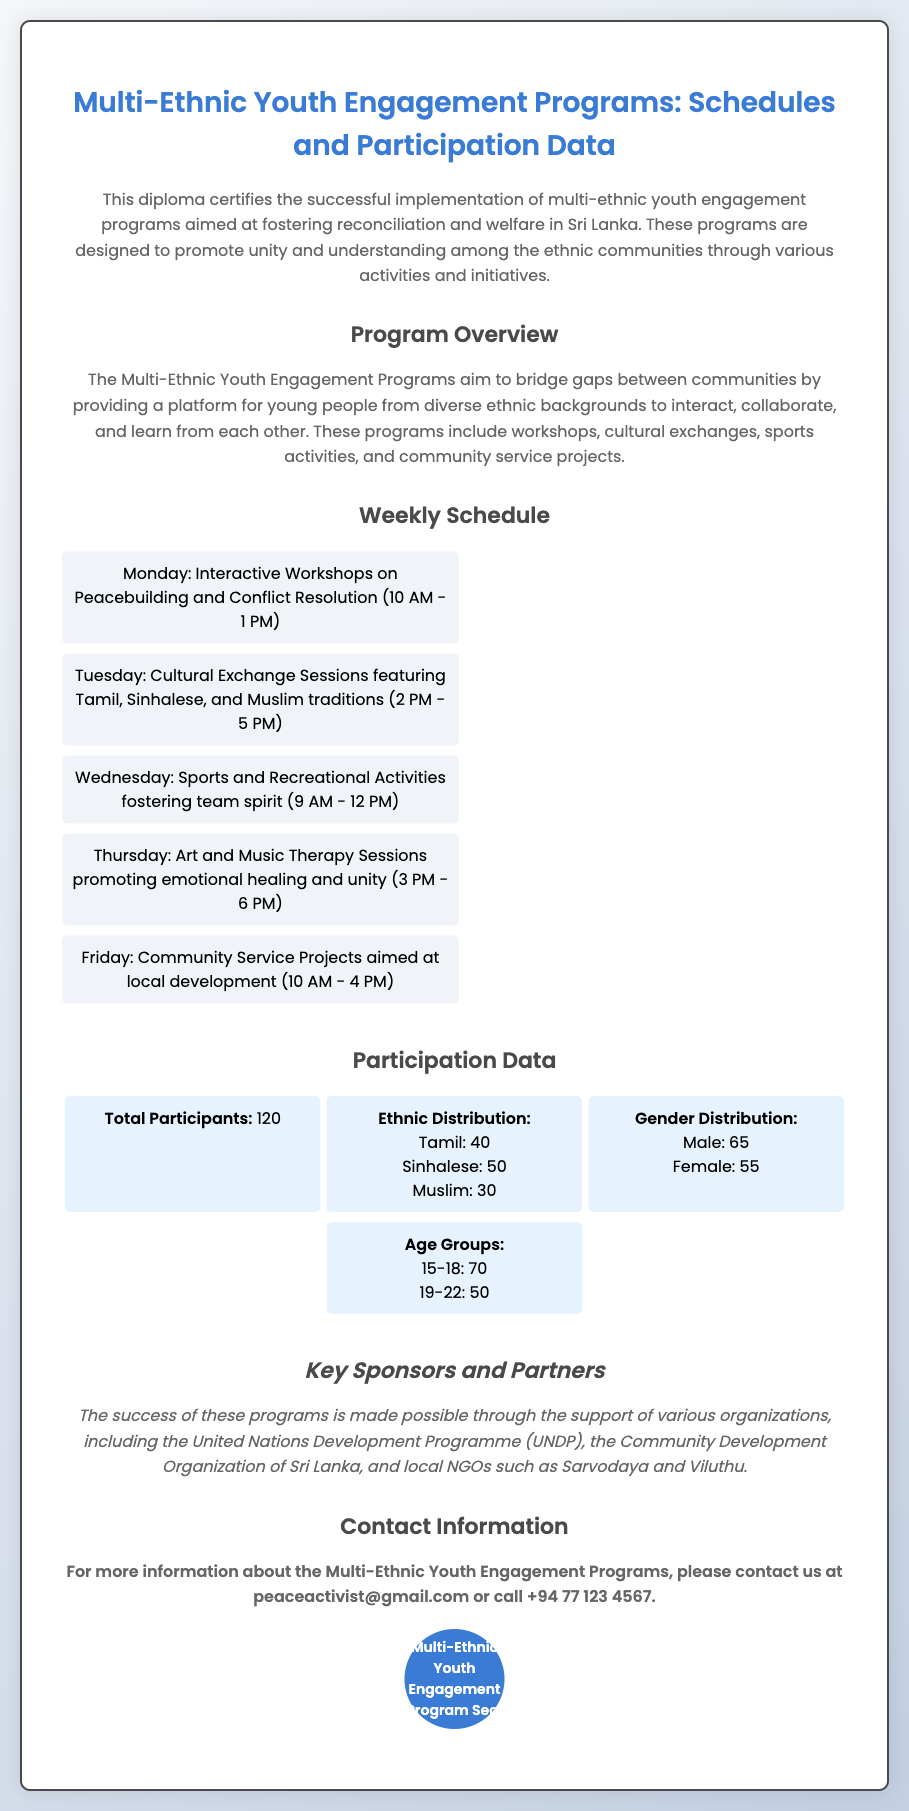what is the title of the diploma? The title clearly states the purpose of the diploma, highlighting the focus on youth engagement in a multi-ethnic context.
Answer: Multi-Ethnic Youth Engagement Programs: Schedules and Participation Data how many total participants are there? The total number of participants is specified directly in the participation data section of the document.
Answer: 120 what day is the community service project scheduled? The schedule specifies which day each program is set to occur, including the community service project.
Answer: Friday what is the age group with the highest number of participants? The age group data provides two ranges, showing which has more participants.
Answer: 15-18 who are some key sponsors of the programs? The document lists organizations that support the programs, which are mentioned in the sponsors section.
Answer: United Nations Development Programme (UNDP) how many females participated in the program? The gender distribution section provides a specific count for female participants.
Answer: 55 what type of activities are included in the programs? The program overview mentions various activities designed to engage the youth and promote reconciliation.
Answer: Workshops, cultural exchanges, sports activities, community service projects what is the timing for the interactive workshops? The weekly schedule provides specific times for each activity, including the interactive workshops.
Answer: 10 AM - 1 PM what is the ethnic distribution of participants? The participation data section breaks down participants by their ethnic backgrounds.
Answer: Tamil: 40, Sinhalese: 50, Muslim: 30 